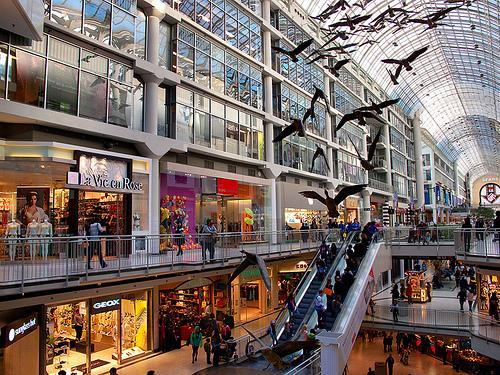What is this type of building called?

Choices:
A) library
B) mall
C) supermarket
D) deli mall 